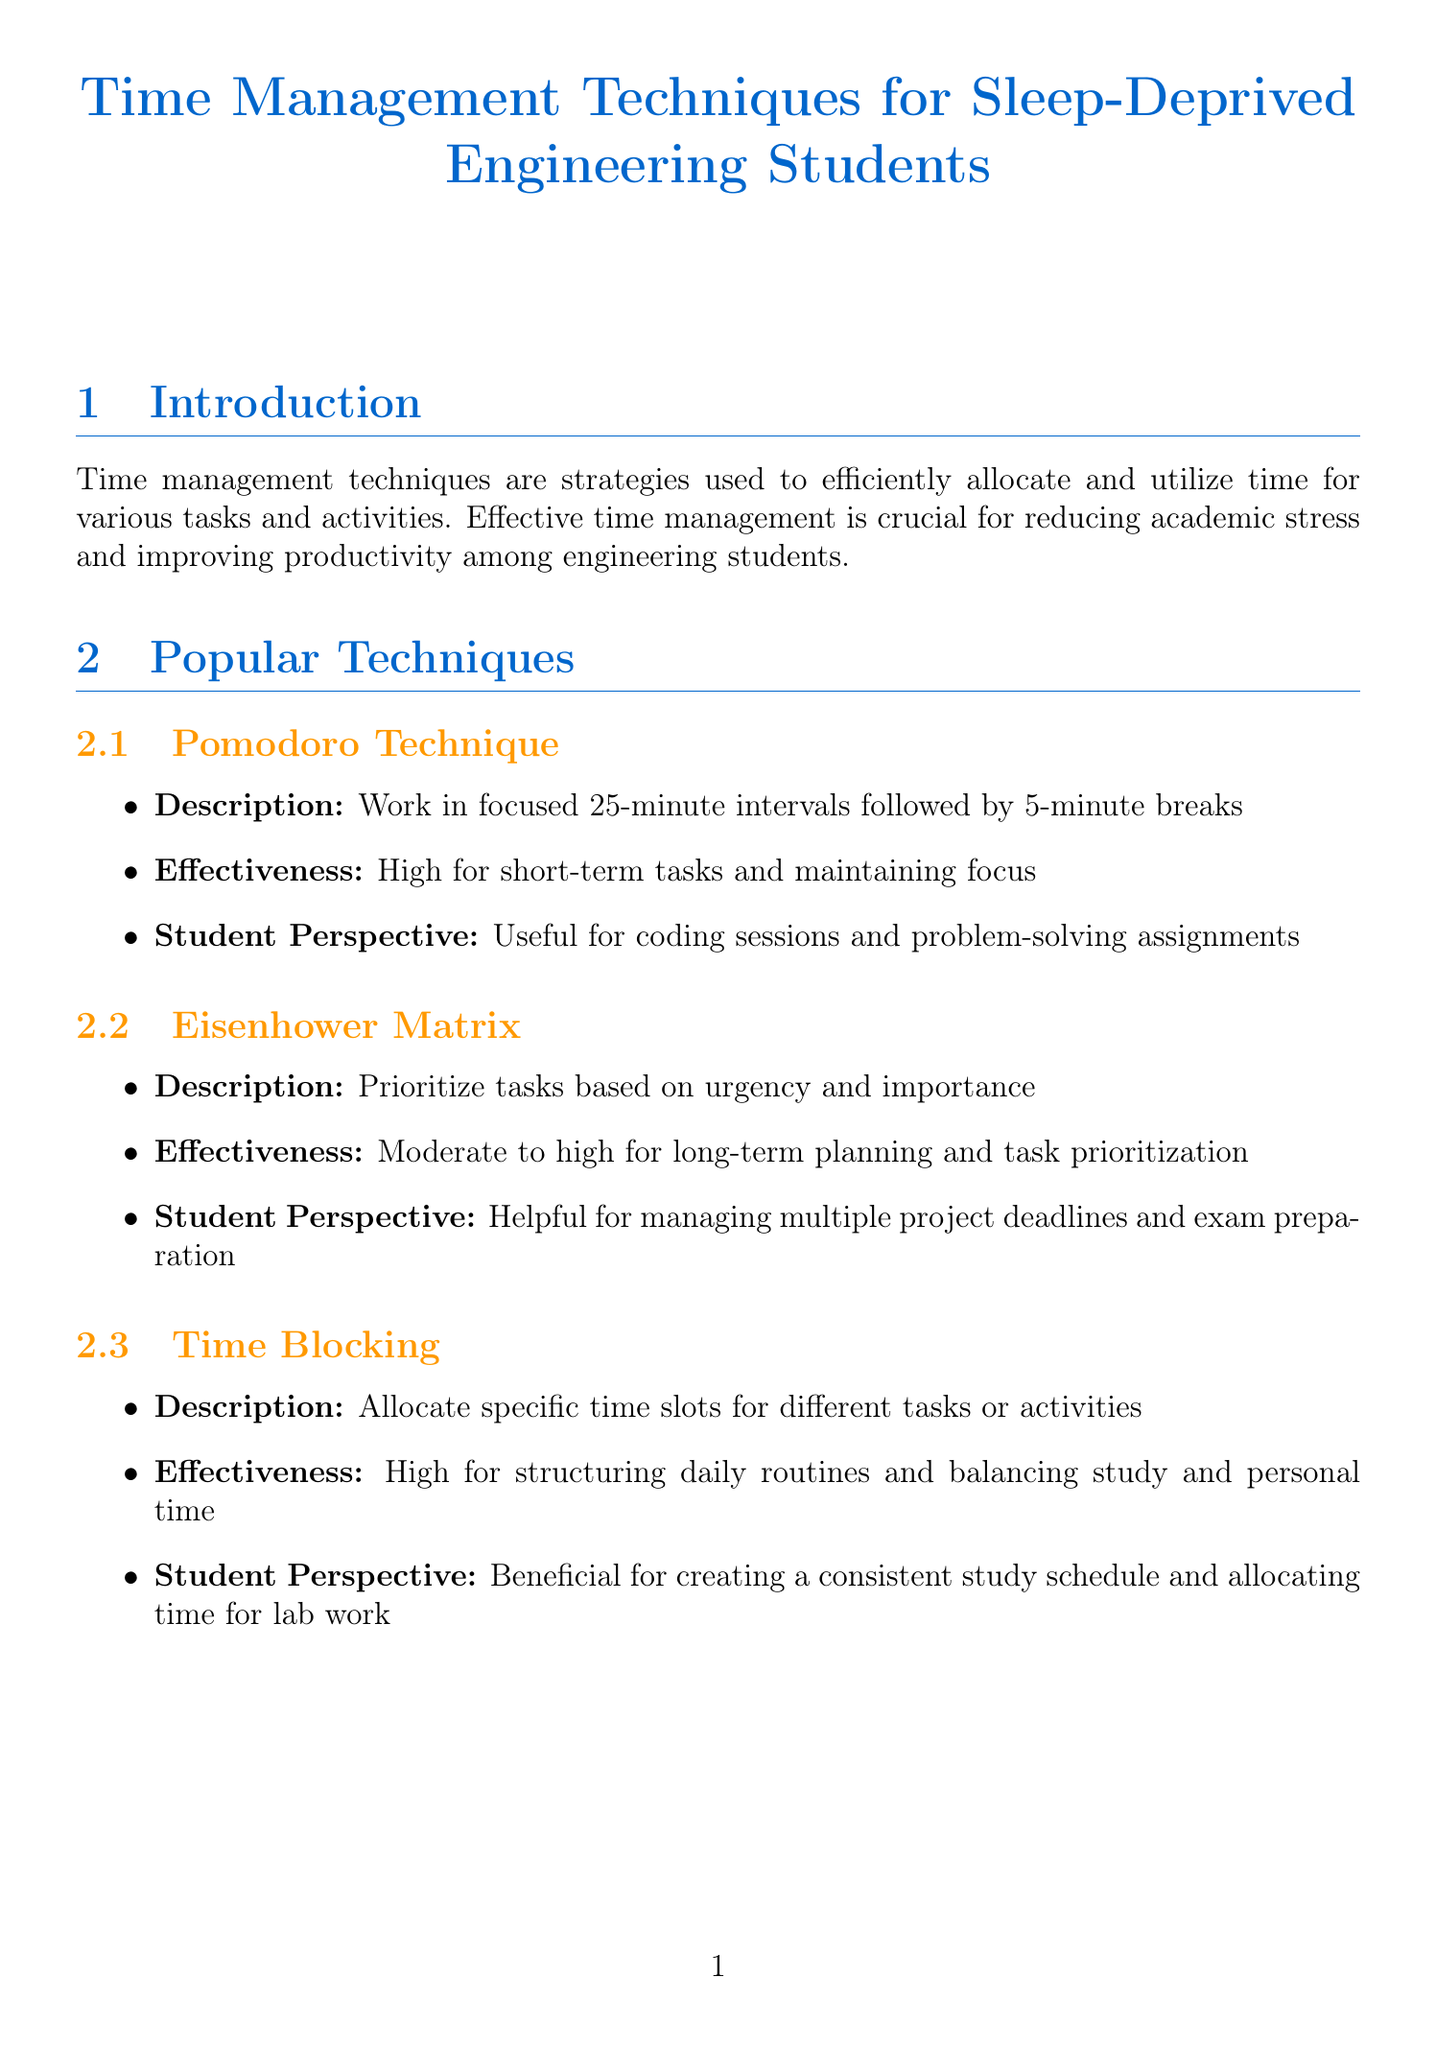What are time management techniques? Time management techniques are defined in the introduction as strategies used to efficiently allocate and utilize time for various tasks and activities.
Answer: Strategies used to efficiently allocate and utilize time What is the importance of time management for engineering students? The document states that effective time management is crucial for reducing academic stress and improving productivity among engineering students.
Answer: Reducing academic stress and improving productivity What is the effectiveness rating for the Pomodoro Technique for stress reduction? The effectiveness comparison table shows the rating for stress reduction for the Pomodoro Technique.
Answer: 8 Which technique reported the highest effectiveness for stress reduction? According to the effectiveness comparison, Time Blocking had the highest rating for stress reduction.
Answer: Time Blocking How many engineering students were surveyed at MIT? The case study from MIT specifies that 500 engineering students were surveyed.
Answer: 500 What percentage decrease in stress levels was reported by students at MIT using time management techniques? The case study mentions a 30% lower stress level reported by students using time management techniques.
Answer: 30% Which time management technique was the top technique at Stanford University? The case study from Stanford mentions that the Pomodoro Technique was the top technique used by the students.
Answer: Pomodoro Technique What is a practical tip for implementing time management techniques? The practical tips section provides several tips, and one example includes using apps like Todoist or Trello.
Answer: Use apps like Todoist or Trello What is the overall conclusion drawn in the report? The conclusion summarizes the effectiveness of time management techniques in reducing academic stress and improving productivity.
Answer: Significantly reduce academic stress and improve productivity What is recommended for individual study habits according to the conclusion? The conclusion states the recommendation is to experiment with different techniques to find the most suitable approach.
Answer: Experiment with different techniques 